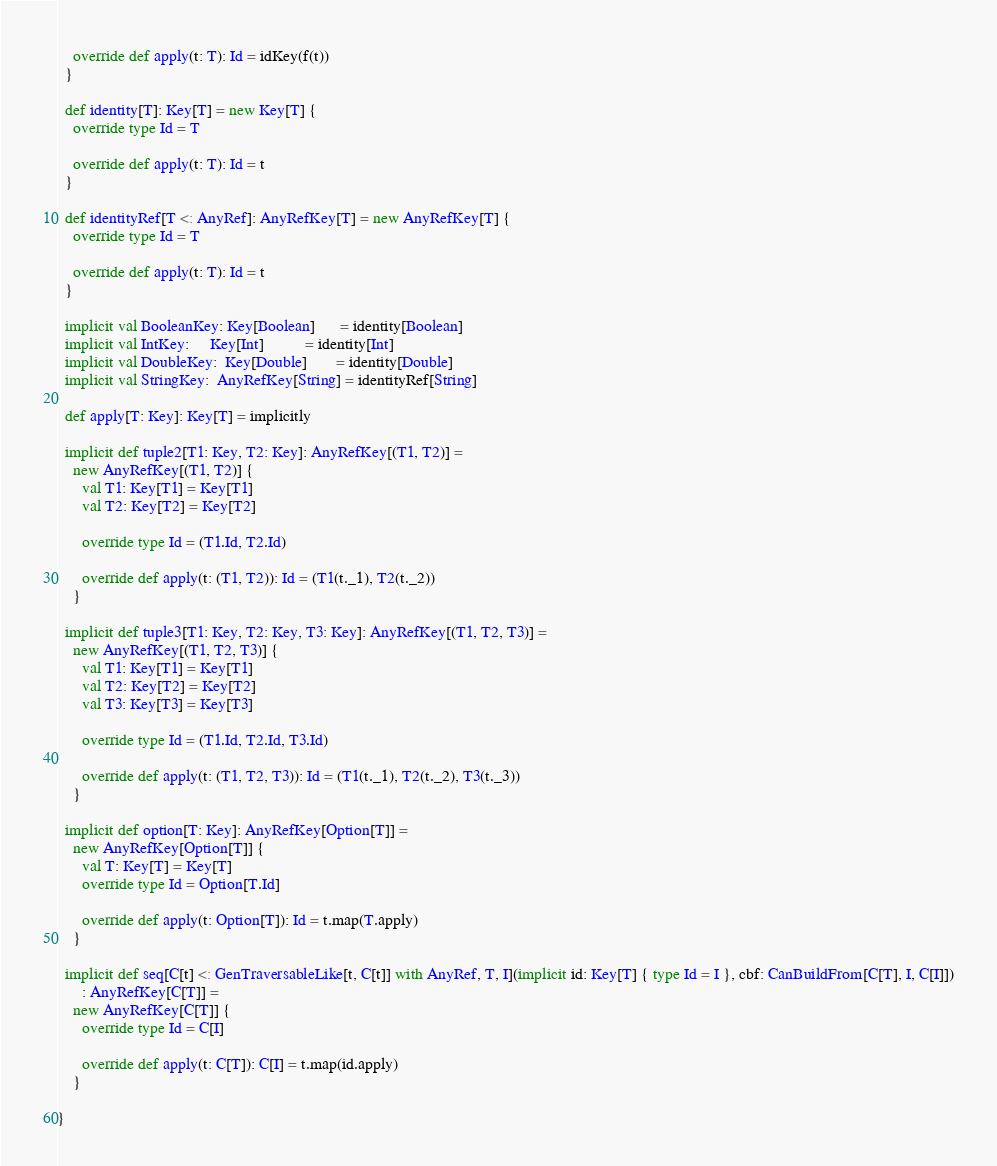<code> <loc_0><loc_0><loc_500><loc_500><_Scala_>
    override def apply(t: T): Id = idKey(f(t))
  }

  def identity[T]: Key[T] = new Key[T] {
    override type Id = T

    override def apply(t: T): Id = t
  }

  def identityRef[T <: AnyRef]: AnyRefKey[T] = new AnyRefKey[T] {
    override type Id = T

    override def apply(t: T): Id = t
  }

  implicit val BooleanKey: Key[Boolean]      = identity[Boolean]
  implicit val IntKey:     Key[Int]          = identity[Int]
  implicit val DoubleKey:  Key[Double]       = identity[Double]
  implicit val StringKey:  AnyRefKey[String] = identityRef[String]

  def apply[T: Key]: Key[T] = implicitly

  implicit def tuple2[T1: Key, T2: Key]: AnyRefKey[(T1, T2)] =
    new AnyRefKey[(T1, T2)] {
      val T1: Key[T1] = Key[T1]
      val T2: Key[T2] = Key[T2]

      override type Id = (T1.Id, T2.Id)

      override def apply(t: (T1, T2)): Id = (T1(t._1), T2(t._2))
    }

  implicit def tuple3[T1: Key, T2: Key, T3: Key]: AnyRefKey[(T1, T2, T3)] =
    new AnyRefKey[(T1, T2, T3)] {
      val T1: Key[T1] = Key[T1]
      val T2: Key[T2] = Key[T2]
      val T3: Key[T3] = Key[T3]

      override type Id = (T1.Id, T2.Id, T3.Id)

      override def apply(t: (T1, T2, T3)): Id = (T1(t._1), T2(t._2), T3(t._3))
    }

  implicit def option[T: Key]: AnyRefKey[Option[T]] =
    new AnyRefKey[Option[T]] {
      val T: Key[T] = Key[T]
      override type Id = Option[T.Id]

      override def apply(t: Option[T]): Id = t.map(T.apply)
    }

  implicit def seq[C[t] <: GenTraversableLike[t, C[t]] with AnyRef, T, I](implicit id: Key[T] { type Id = I }, cbf: CanBuildFrom[C[T], I, C[I]])
      : AnyRefKey[C[T]] =
    new AnyRefKey[C[T]] {
      override type Id = C[I]

      override def apply(t: C[T]): C[I] = t.map(id.apply)
    }

}
</code> 